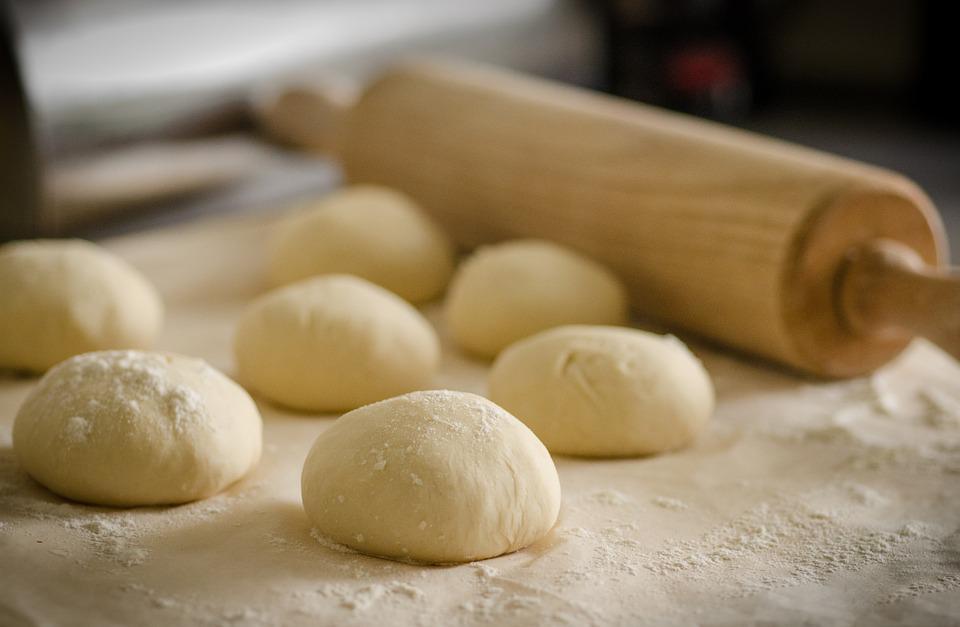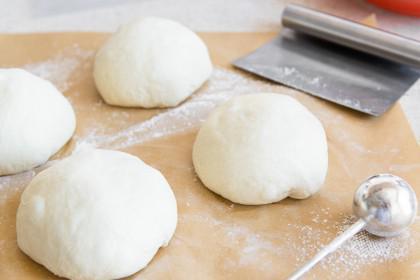The first image is the image on the left, the second image is the image on the right. For the images displayed, is the sentence "A wooden rolling pin is seen in the image on the left." factually correct? Answer yes or no. Yes. The first image is the image on the left, the second image is the image on the right. Considering the images on both sides, is "In one of the images there is a rolling pin." valid? Answer yes or no. Yes. 